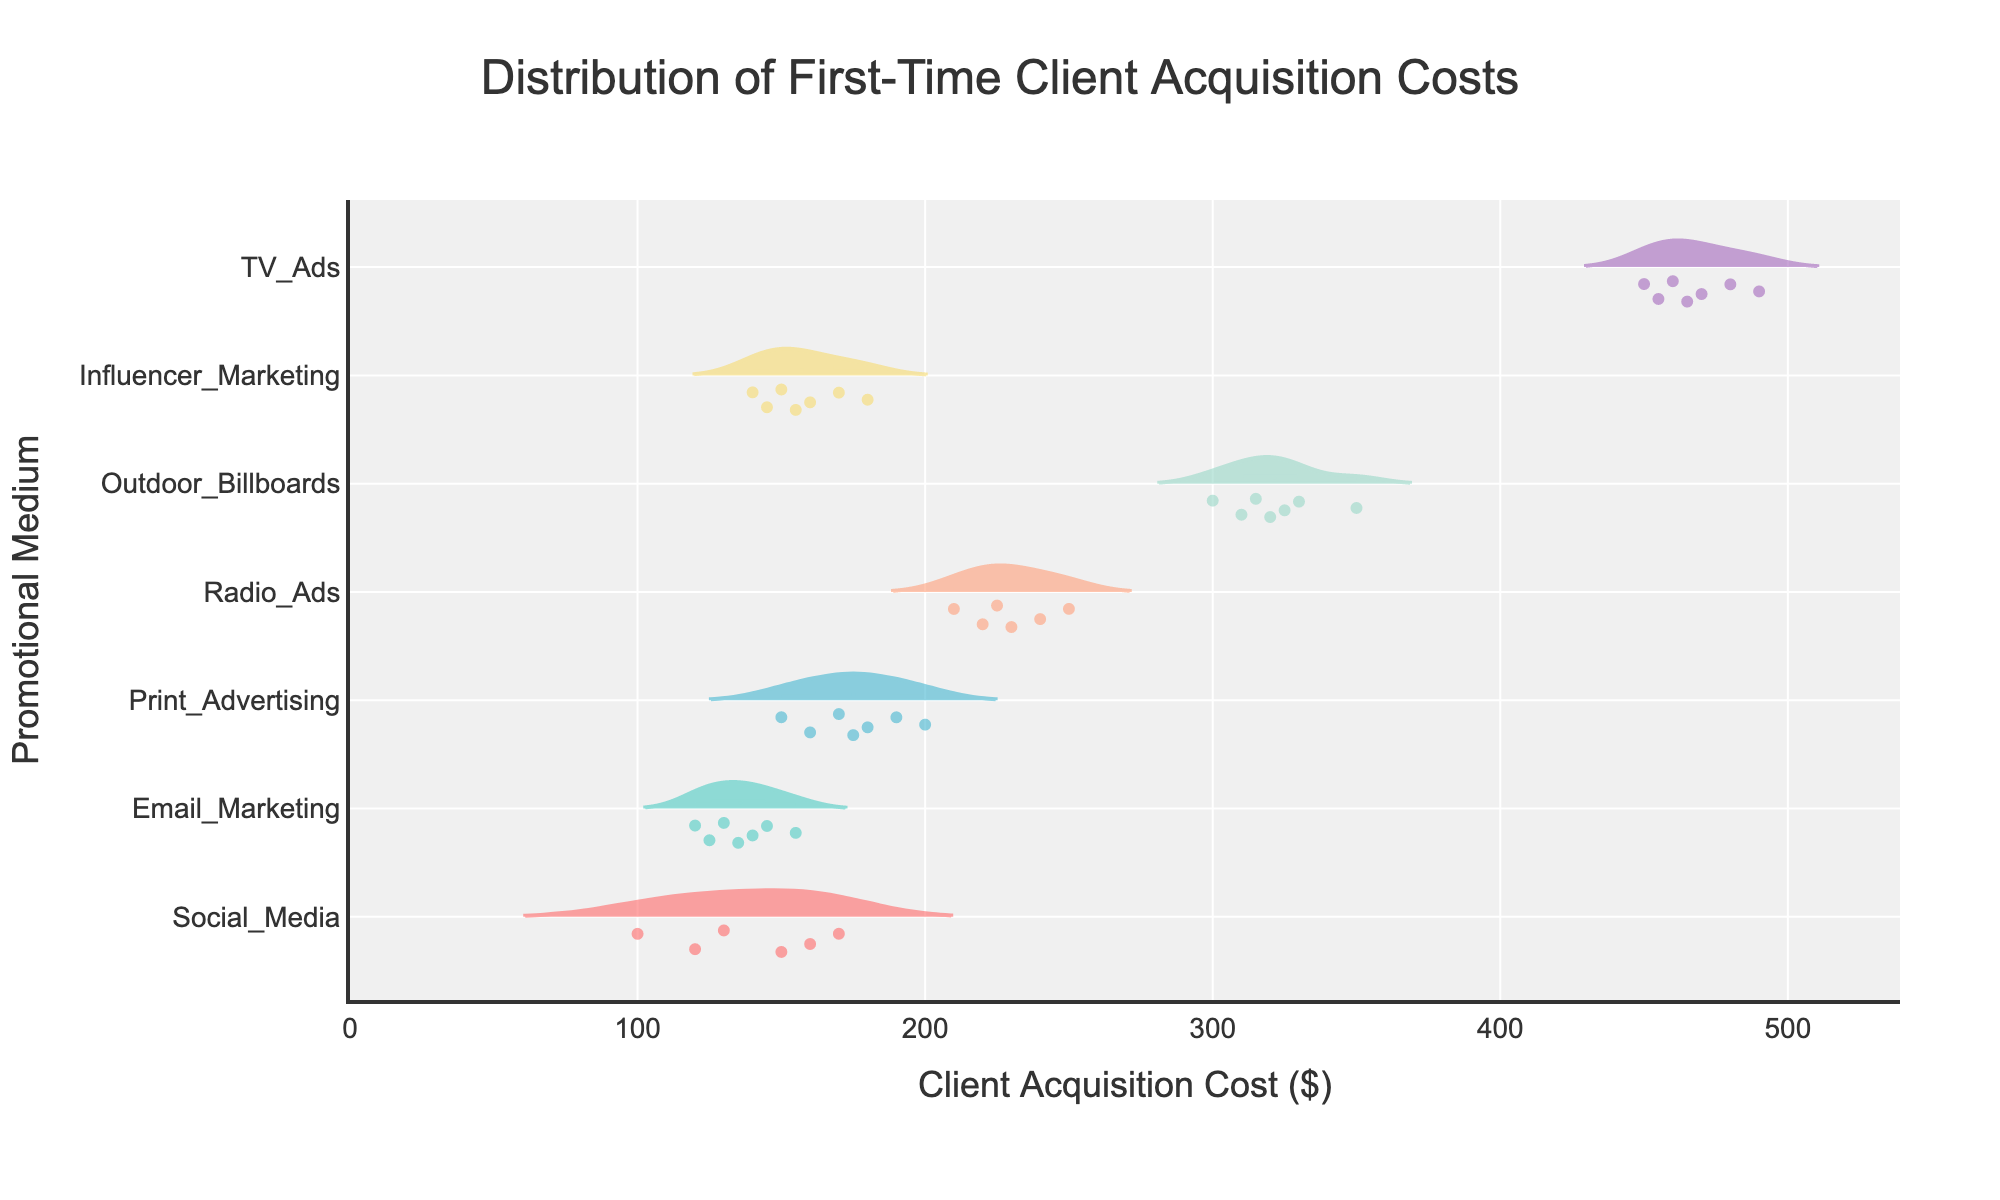what is the range of client acquisition costs for social media? To find the range, we look at the lowest and highest data points for social media in the violin plot. The data points for social media range from $100 to $170. So, the range is $170 - $100 = $70.
Answer: $70 which promotional medium has the highest mean client acquisition cost? The violin plot includes mean lines for each promotional medium. The TV ads plot has the highest mean line compared to all other promotional mediums, indicating it has the highest mean client acquisition cost.
Answer: TV Ads how does the distribution of client acquisition costs for email marketing compare to influencer marketing? By observing both the spread and central tendency of the distributions, we note that both have similar distributions in terms of range and median lines, but email marketing appears to have a tighter spread, indicating less variability than influencer marketing.
Answer: Less variability what is the median client acquisition cost for print advertising? The median is visible as a horizontal line in the center of the violin plot for the print advertising group. The position of this line indicates the median client acquisition cost is around $175.
Answer: $175 how many data points are there in the outdoor billboards group? The violin plot shows all individual data points using dots. We can count these points for outdoor billboards, which sum up to 7 dots.
Answer: 7 which promotional medium has the widest spread in client acquisition costs? To find the promotional medium with the widest spread, compare the range in the horizontal direction for each violin plot. Outdoor billboards have the widest spread, ranging from $300 to $350.
Answer: Outdoor Billboards which promotional medium has the narrowest spread in client acquisition costs? By comparing the range in the horizontal direction for all violin plots, email marketing shows the narrowest spread, ranging approximately from $120 to $155.
Answer: Email Marketing what is the mean client acquisition cost for radio ads? The mean is indicated by a distinct line within the violin plot. For radio ads, this mean line is around $230.
Answer: $230 how does the mean client acquisition cost for social media compare to print advertising? By comparing the mean lines of both the social media and print advertising violin plots, we find that the mean client acquisition cost for print advertising is higher than for social media.
Answer: Print advertising is higher do any promotional mediums have any outliers in their distribution? By observing dots outside the expected range (box plot limits) within the violin plots, we do not see clear outliers for any promotional medium; all data points appear within the interquartile ranges.
Answer: No outliers 